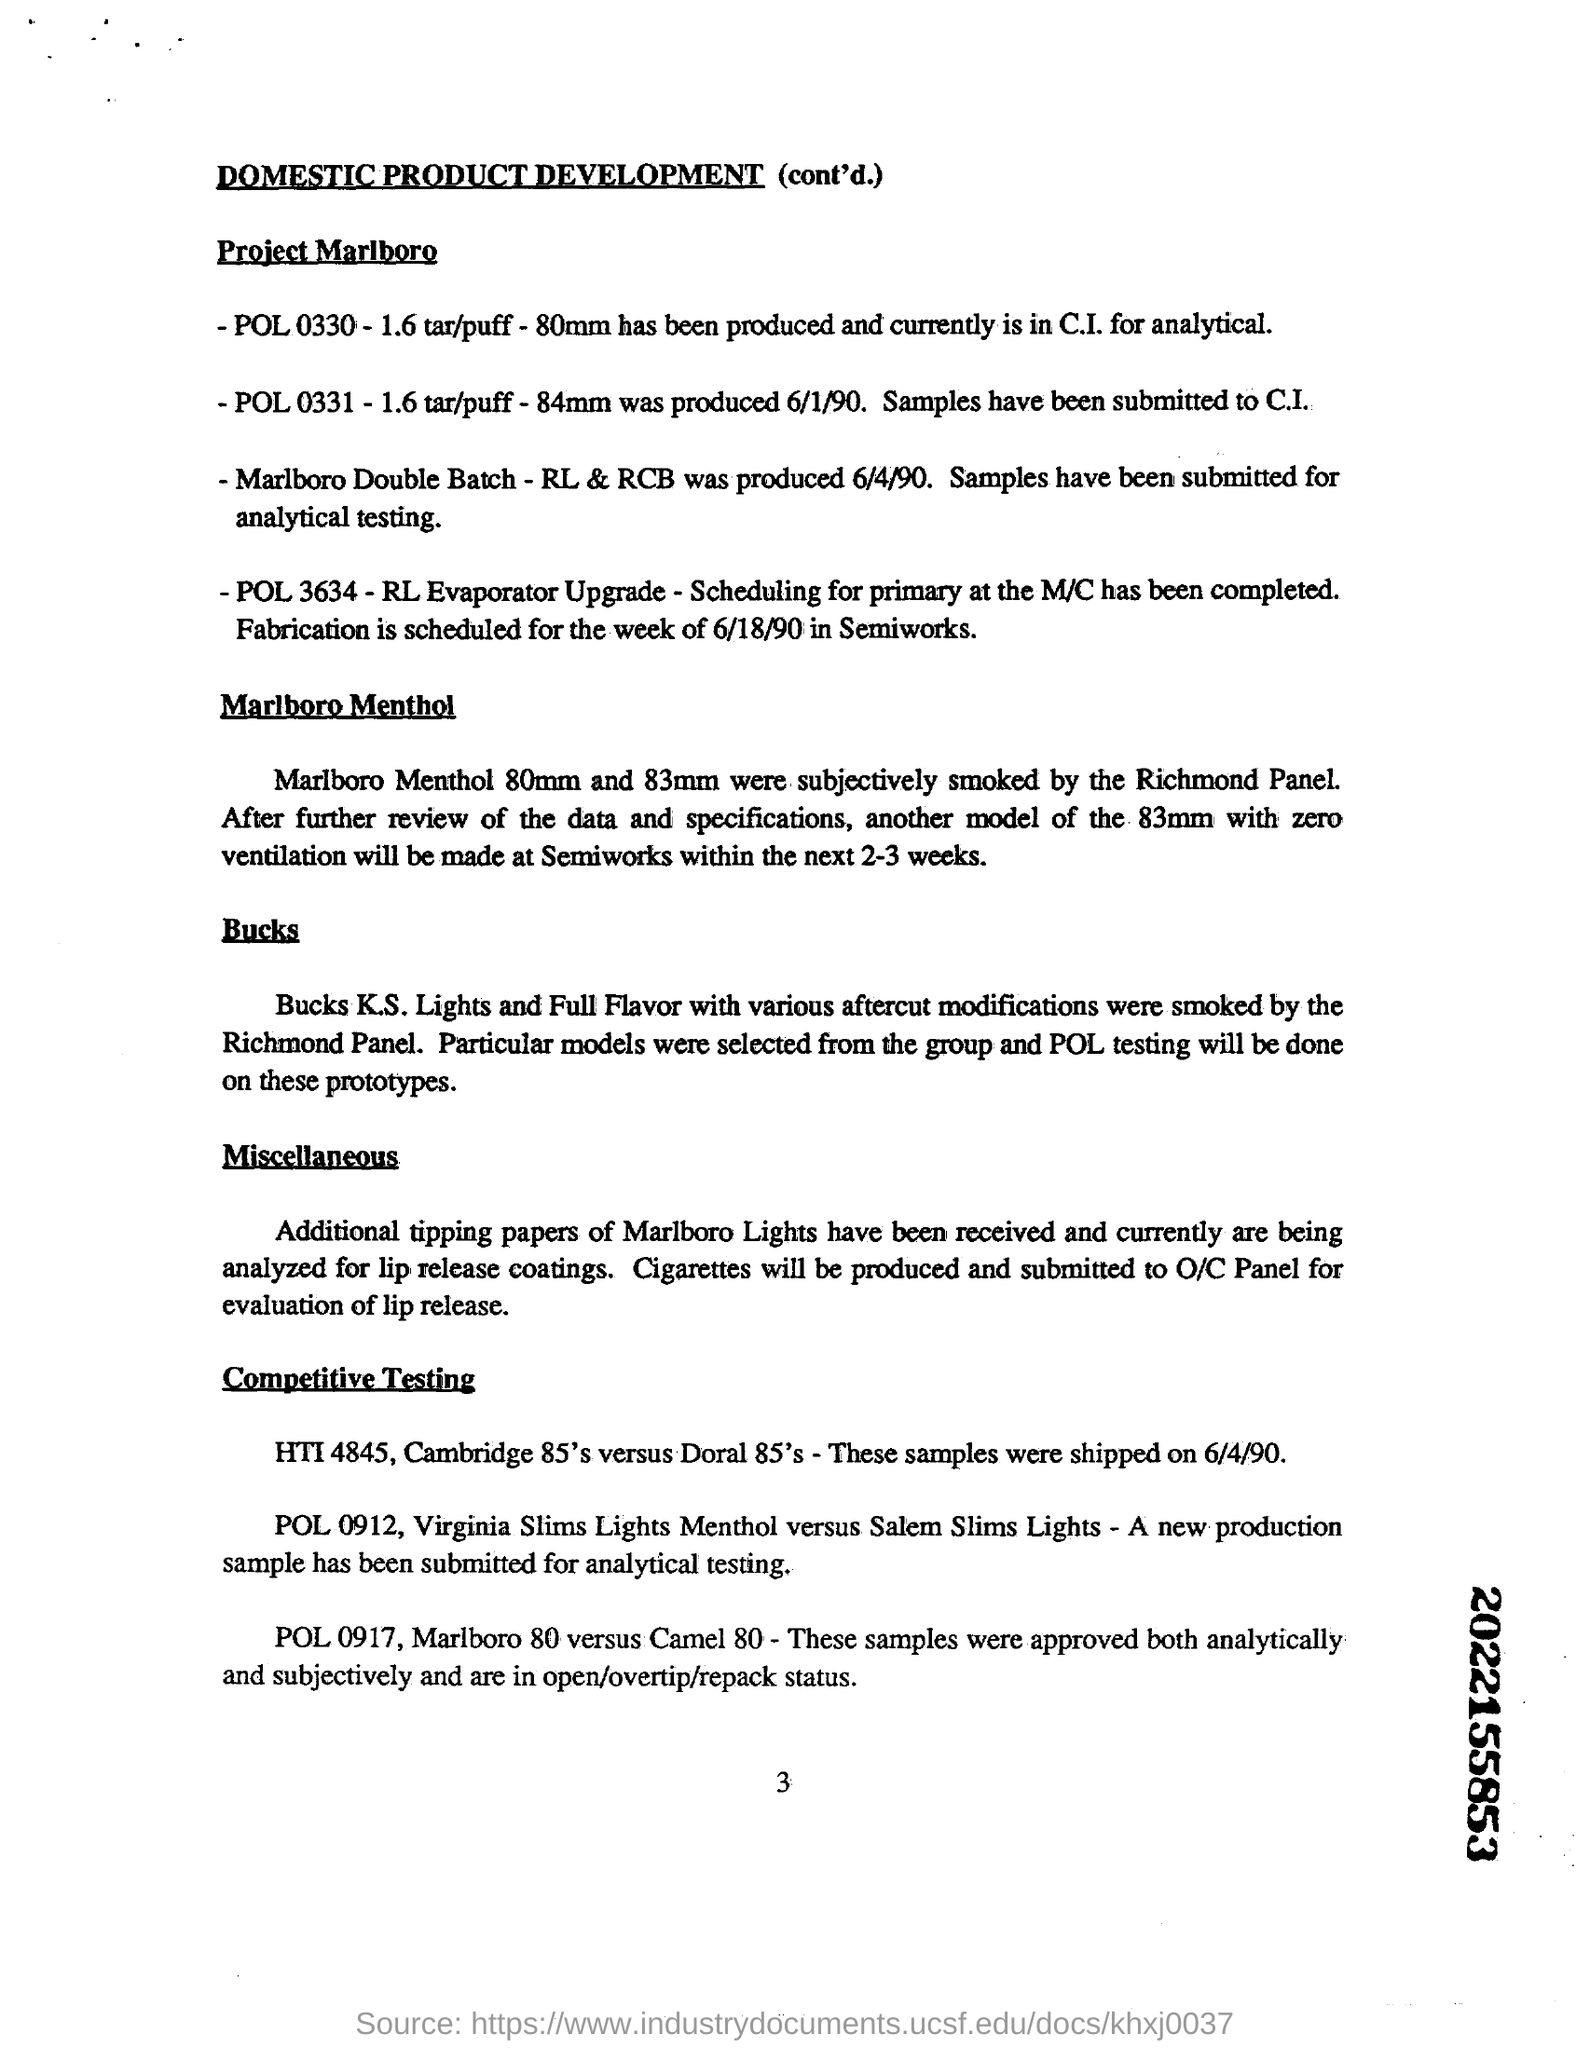what mm Marlboro Menthol were subjectively smoked by the Richmond Panel
 80mm and 83mm 